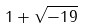<formula> <loc_0><loc_0><loc_500><loc_500>1 + { \sqrt { - 1 9 } }</formula> 